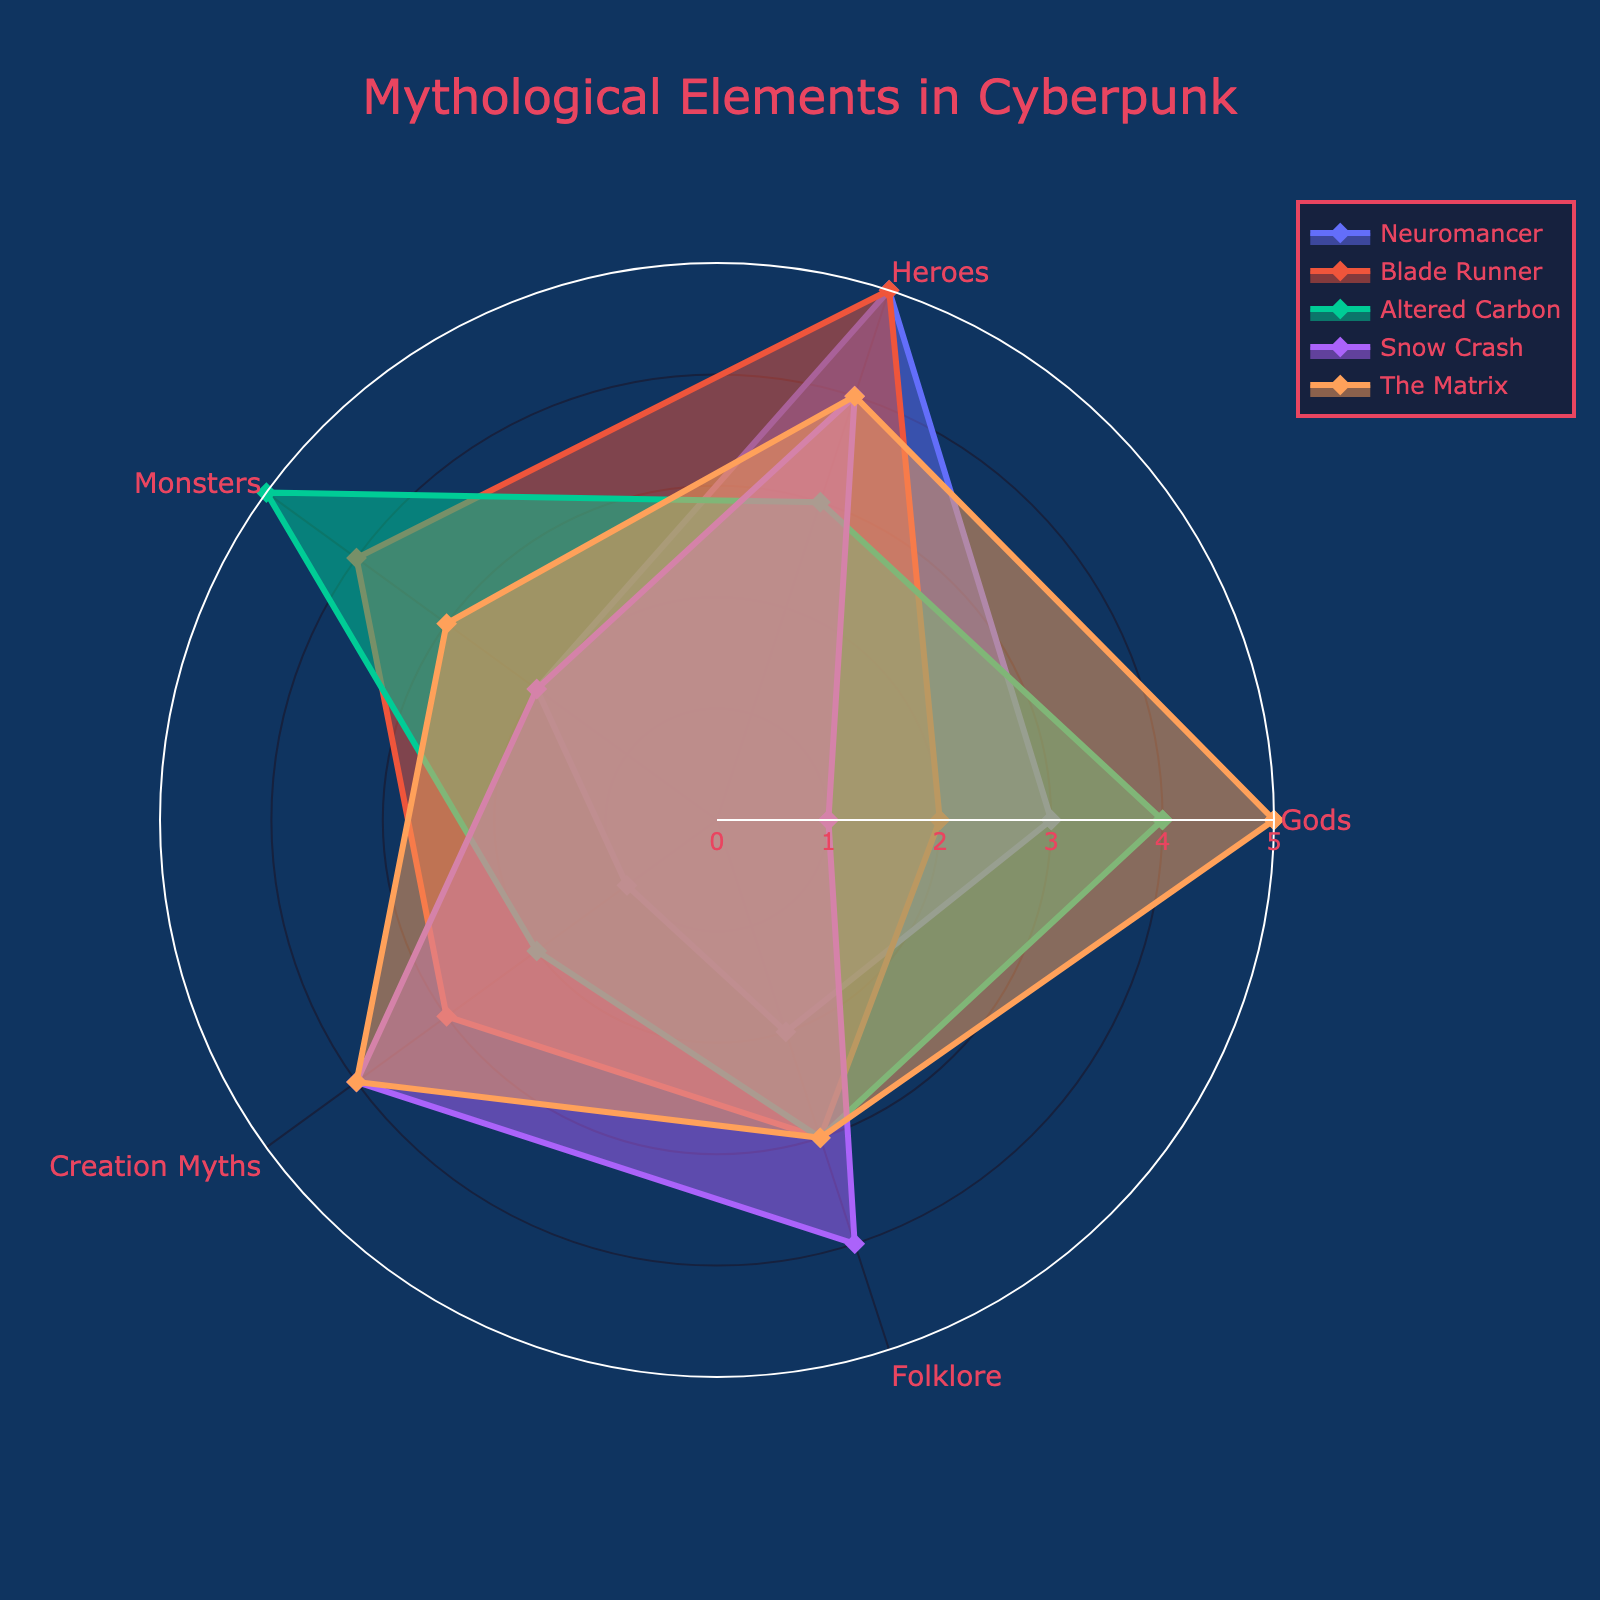What's the title of the radar chart? The title is usually prominently displayed on the figure. In this case, the title is set to "Mythological Elements in Cyberpunk" in the provided code.
Answer: Mythological Elements in Cyberpunk Which mythological element is most prominently featured in "Neuromancer"? To find the most prominent element for "Neuromancer," look at the highest value in its corresponding radar chart section. Here, "Heroes" has the highest value of 5.
Answer: Heroes Between "Blade Runner" and "Altered Carbon," which depicts more aspects of creation myths? Compare the values for "Creation Myths" in both "Blade Runner" and "Altered Carbon." "Blade Runner" has a value of 3, while "Altered Carbon" has a value of 2.
Answer: Blade Runner What is the average presence of monsters across all titles? First, sum the values for monsters across all titles (2 + 4 + 5 + 2 + 3) which equals 16. Then, divide by the number of titles (5). So, 16/5 = 3.2.
Answer: 3.2 Which mythological element shows the greatest variability across the titles? To determine this, see which element has the widest range of values. "Creation Myths" range from 1 to 4, "Gods" range from 1 to 5, "Heroes" from 3 to 5, "Monsters" from 2 to 5, and "Folklore" from 2 to 4. "Gods" have the widest range (1-5).
Answer: Gods What is the combined score for folklore in "Snow Crash" and "The Matrix"? Add the respective values for "Folklore" in both titles: 4 (Snow Crash) + 3 (The Matrix), which equals 7.
Answer: 7 Which title has the least depiction of gods? Refer to the values for "Gods" in each title. "Snow Crash" has the lowest value of 1.
Answer: Snow Crash Does "The Matrix" show a greater presence of heroes or monsters? Compare the values for "Heroes" and "Monsters" in "The Matrix." "Heroes" has a value of 4, and "Monsters" has a value of 3, so "Heroes" is greater.
Answer: Heroes In which mythological element do "Neuromancer" and "Blade Runner" have the same value? Compare values across the elements for both titles. For "Heroes," both have a value of 5, and for "Folklore," both have 2.
Answer: Heroes, Folklore 